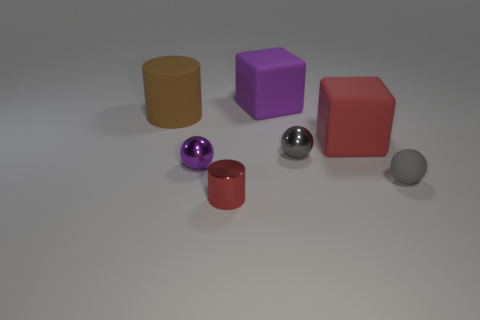How many other tiny things are the same color as the small rubber object?
Give a very brief answer. 1. How many spheres have the same material as the tiny red thing?
Your response must be concise. 2. What number of cubes are large brown rubber objects or large things?
Your response must be concise. 2. There is a sphere on the left side of the red object that is on the left side of the cube that is on the left side of the large red block; how big is it?
Provide a short and direct response. Small. There is a object that is on the left side of the small red thing and in front of the large matte cylinder; what color is it?
Your response must be concise. Purple. Is the size of the purple shiny sphere the same as the red thing that is behind the gray matte object?
Your response must be concise. No. Is there anything else that is the same shape as the purple rubber thing?
Your answer should be compact. Yes. There is a rubber thing that is the same shape as the tiny purple shiny thing; what is its color?
Your response must be concise. Gray. Is the purple matte object the same size as the brown matte cylinder?
Make the answer very short. Yes. How many other objects are the same size as the purple rubber cube?
Give a very brief answer. 2. 